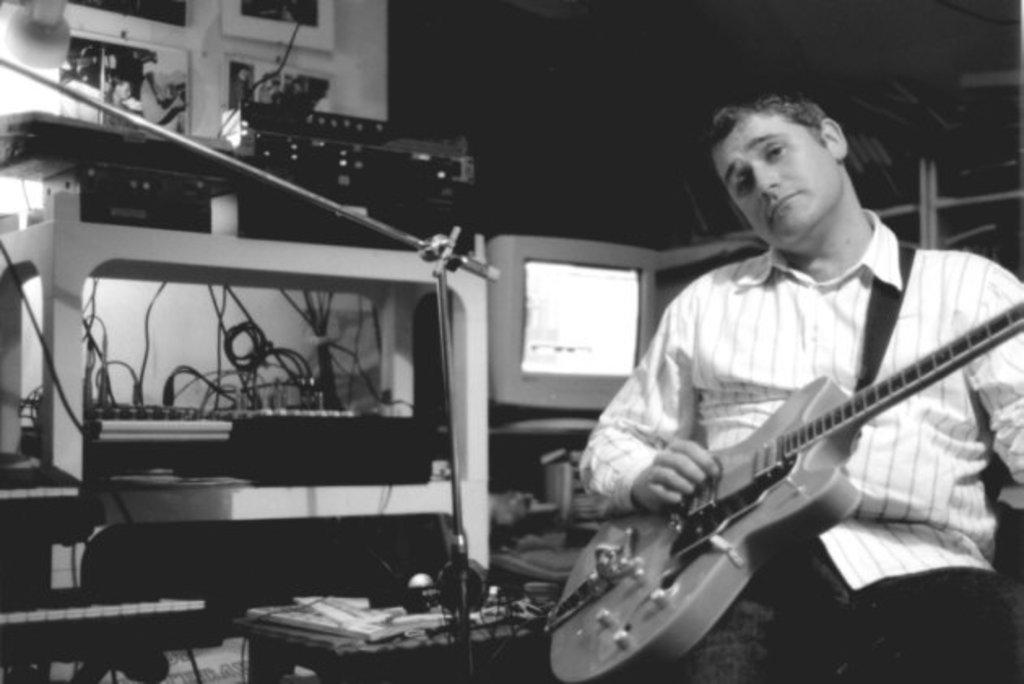Who is present in the image? There is a man in the image. What is the man doing in the image? The man is sitting in the image. What object is the man holding in his hand? The man is holding a guitar in his hand. What color scheme is used in the image? The image is in black and white color. What type of box can be seen in the image? There is no box present in the image. Is the man playing with a ball in the image? There is no ball present in the image. 